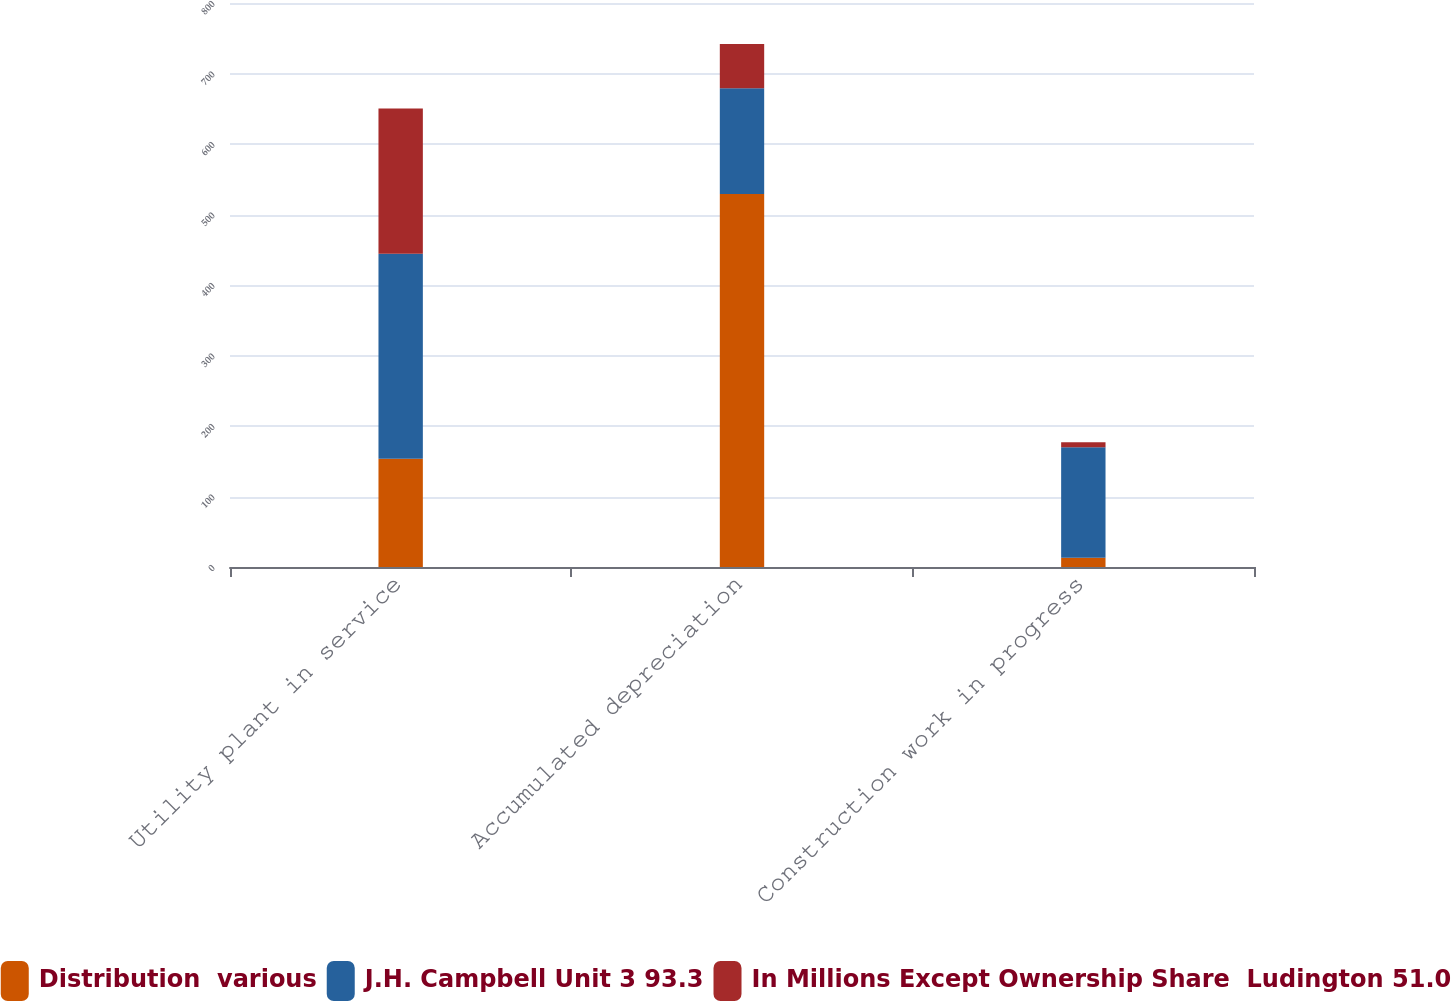Convert chart to OTSL. <chart><loc_0><loc_0><loc_500><loc_500><stacked_bar_chart><ecel><fcel>Utility plant in service<fcel>Accumulated depreciation<fcel>Construction work in progress<nl><fcel>Distribution  various<fcel>153.5<fcel>529<fcel>13<nl><fcel>J.H. Campbell Unit 3 93.3<fcel>291<fcel>150<fcel>157<nl><fcel>In Millions Except Ownership Share  Ludington 51.0<fcel>206<fcel>63<fcel>7<nl></chart> 